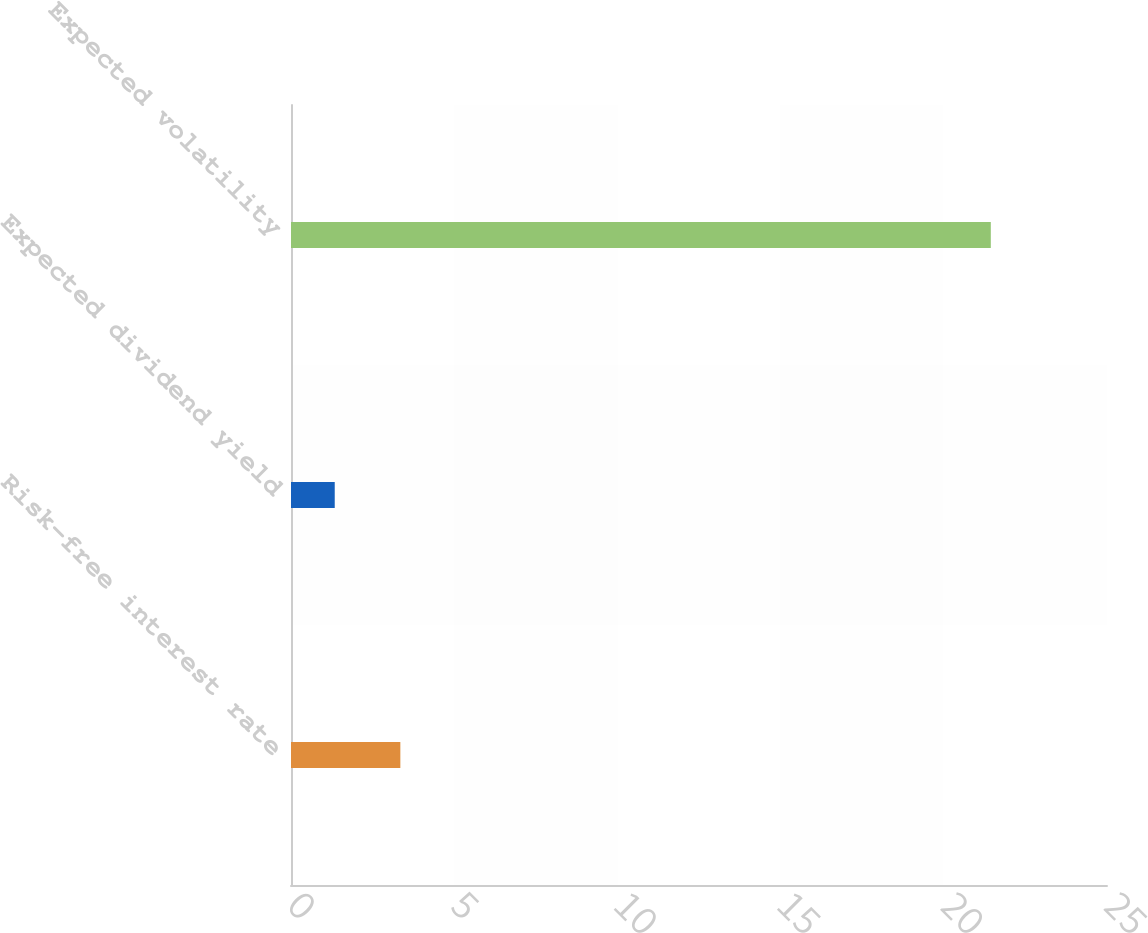Convert chart. <chart><loc_0><loc_0><loc_500><loc_500><bar_chart><fcel>Risk-free interest rate<fcel>Expected dividend yield<fcel>Expected volatility<nl><fcel>3.35<fcel>1.34<fcel>21.44<nl></chart> 